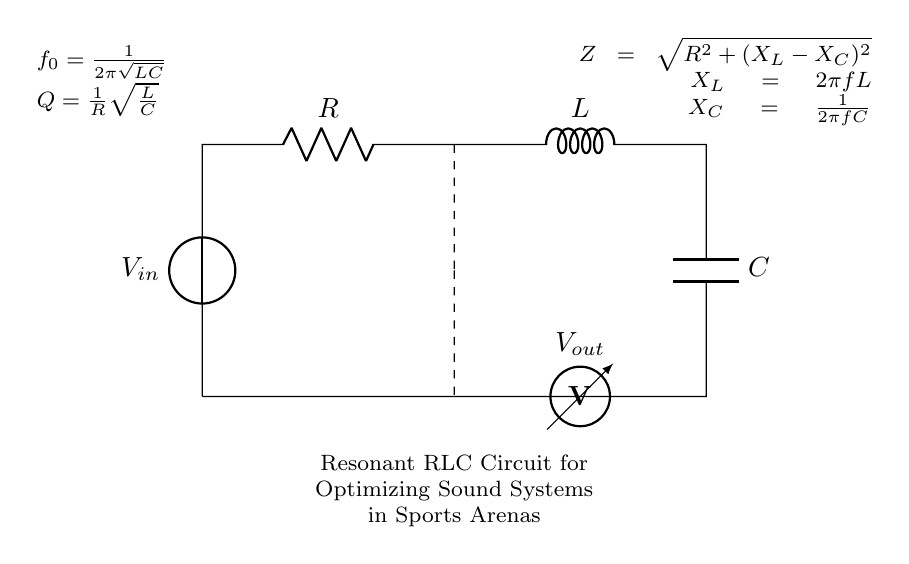What does the circuit represent? The circuit represents a resonant RLC circuit designed for optimizing sound systems in sports arenas, as indicated in the diagram.
Answer: resonant RLC circuit What components are included in the circuit? The circuit includes a resistor, inductor, and capacitor, as specified in the labels next to the components.
Answer: resistor, inductor, capacitor What is the natural frequency formula shown in the diagram? The diagram shows the natural frequency formula as f0 = 1 / (2π√(LC)), which defines how the circuit resonates based on the inductor and capacitor values.
Answer: f0 = 1 / (2π√(LC)) What is the significance of quality factor Q in this circuit? The quality factor Q is significant as it is defined as Q = 1 / R√(L/C), which impacts the bandwidth and selectivity of the circuit, revealing how underdamped the circuit is.
Answer: Q = 1 / R√(L/C) How is the total impedance Z calculated in this circuit? The impedance Z is calculated using the formula Z = √(R^2 + (X_L - X_C)^2), where X_L is the inductive reactance and X_C is the capacitive reactance, affecting how the circuit responds to AC signals.
Answer: Z = √(R^2 + (X_L - X_C)^2) What is the relationship between the inductor and capacitor in terms of reactance? In the circuit, the relationship is defined by the equations X_L = 2πfL and X_C = 1 / (2πfC), showing how each component contributes to the overall reactance at a given frequency.
Answer: X_L and X_C What does the voltmeter in the diagram measure? The voltmeter measures the output voltage Vout across the capacitor, which is an important parameter in determining the performance of the sound system in the arena.
Answer: Vout 